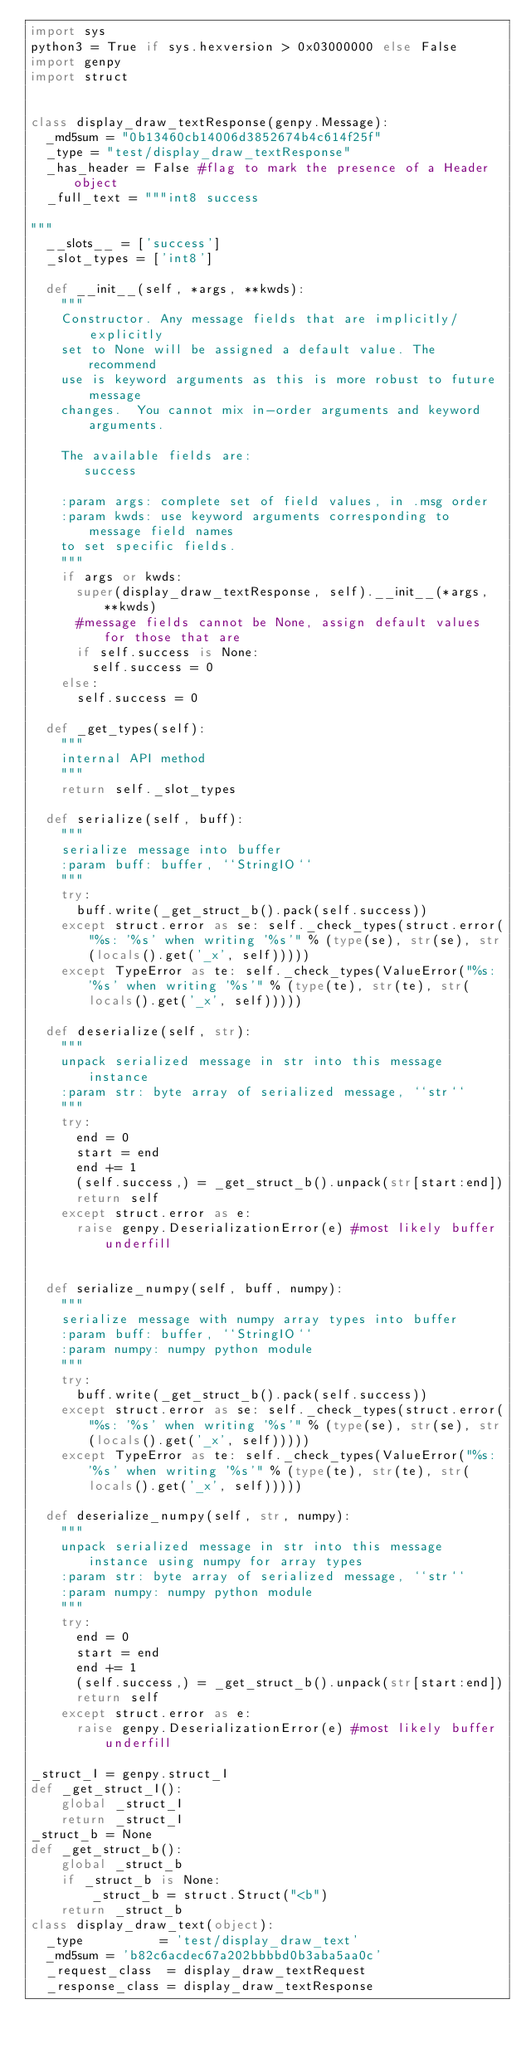<code> <loc_0><loc_0><loc_500><loc_500><_Python_>import sys
python3 = True if sys.hexversion > 0x03000000 else False
import genpy
import struct


class display_draw_textResponse(genpy.Message):
  _md5sum = "0b13460cb14006d3852674b4c614f25f"
  _type = "test/display_draw_textResponse"
  _has_header = False #flag to mark the presence of a Header object
  _full_text = """int8 success

"""
  __slots__ = ['success']
  _slot_types = ['int8']

  def __init__(self, *args, **kwds):
    """
    Constructor. Any message fields that are implicitly/explicitly
    set to None will be assigned a default value. The recommend
    use is keyword arguments as this is more robust to future message
    changes.  You cannot mix in-order arguments and keyword arguments.

    The available fields are:
       success

    :param args: complete set of field values, in .msg order
    :param kwds: use keyword arguments corresponding to message field names
    to set specific fields.
    """
    if args or kwds:
      super(display_draw_textResponse, self).__init__(*args, **kwds)
      #message fields cannot be None, assign default values for those that are
      if self.success is None:
        self.success = 0
    else:
      self.success = 0

  def _get_types(self):
    """
    internal API method
    """
    return self._slot_types

  def serialize(self, buff):
    """
    serialize message into buffer
    :param buff: buffer, ``StringIO``
    """
    try:
      buff.write(_get_struct_b().pack(self.success))
    except struct.error as se: self._check_types(struct.error("%s: '%s' when writing '%s'" % (type(se), str(se), str(locals().get('_x', self)))))
    except TypeError as te: self._check_types(ValueError("%s: '%s' when writing '%s'" % (type(te), str(te), str(locals().get('_x', self)))))

  def deserialize(self, str):
    """
    unpack serialized message in str into this message instance
    :param str: byte array of serialized message, ``str``
    """
    try:
      end = 0
      start = end
      end += 1
      (self.success,) = _get_struct_b().unpack(str[start:end])
      return self
    except struct.error as e:
      raise genpy.DeserializationError(e) #most likely buffer underfill


  def serialize_numpy(self, buff, numpy):
    """
    serialize message with numpy array types into buffer
    :param buff: buffer, ``StringIO``
    :param numpy: numpy python module
    """
    try:
      buff.write(_get_struct_b().pack(self.success))
    except struct.error as se: self._check_types(struct.error("%s: '%s' when writing '%s'" % (type(se), str(se), str(locals().get('_x', self)))))
    except TypeError as te: self._check_types(ValueError("%s: '%s' when writing '%s'" % (type(te), str(te), str(locals().get('_x', self)))))

  def deserialize_numpy(self, str, numpy):
    """
    unpack serialized message in str into this message instance using numpy for array types
    :param str: byte array of serialized message, ``str``
    :param numpy: numpy python module
    """
    try:
      end = 0
      start = end
      end += 1
      (self.success,) = _get_struct_b().unpack(str[start:end])
      return self
    except struct.error as e:
      raise genpy.DeserializationError(e) #most likely buffer underfill

_struct_I = genpy.struct_I
def _get_struct_I():
    global _struct_I
    return _struct_I
_struct_b = None
def _get_struct_b():
    global _struct_b
    if _struct_b is None:
        _struct_b = struct.Struct("<b")
    return _struct_b
class display_draw_text(object):
  _type          = 'test/display_draw_text'
  _md5sum = 'b82c6acdec67a202bbbbd0b3aba5aa0c'
  _request_class  = display_draw_textRequest
  _response_class = display_draw_textResponse
</code> 